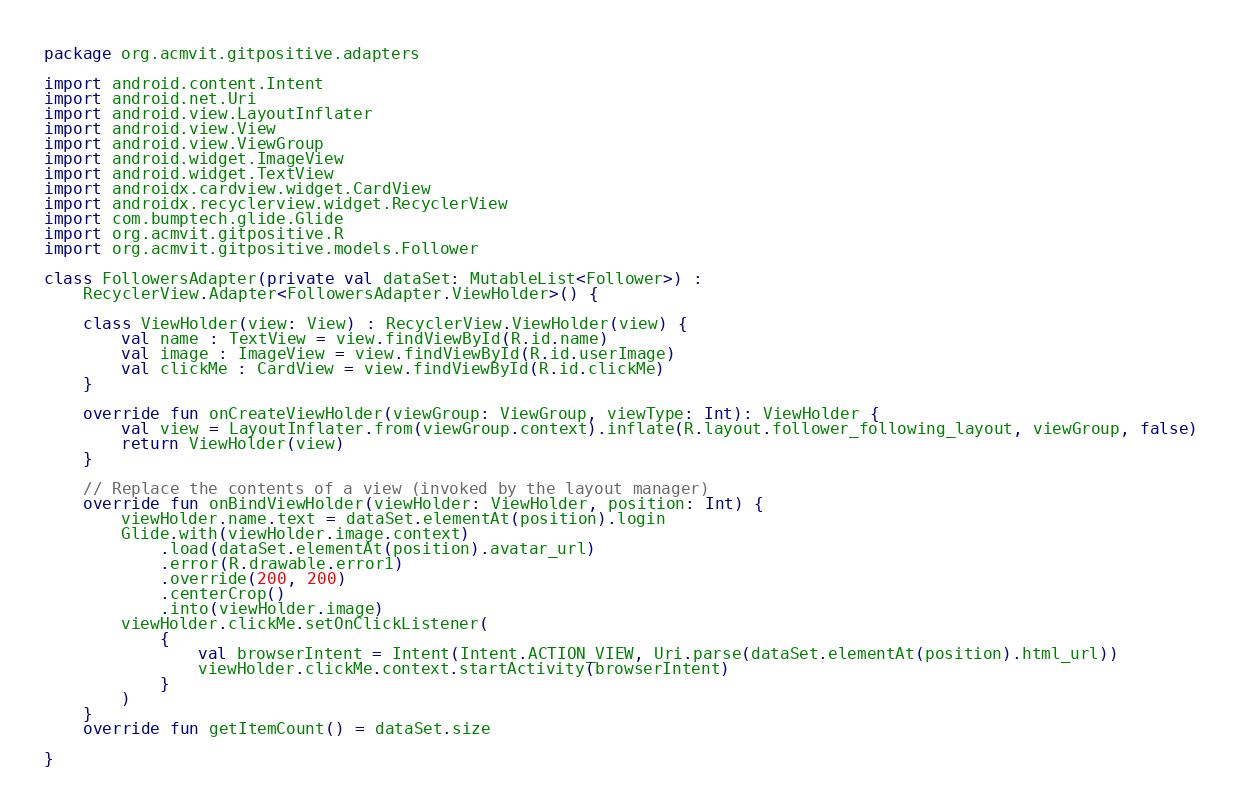<code> <loc_0><loc_0><loc_500><loc_500><_Kotlin_>package org.acmvit.gitpositive.adapters

import android.content.Intent
import android.net.Uri
import android.view.LayoutInflater
import android.view.View
import android.view.ViewGroup
import android.widget.ImageView
import android.widget.TextView
import androidx.cardview.widget.CardView
import androidx.recyclerview.widget.RecyclerView
import com.bumptech.glide.Glide
import org.acmvit.gitpositive.R
import org.acmvit.gitpositive.models.Follower

class FollowersAdapter(private val dataSet: MutableList<Follower>) :
    RecyclerView.Adapter<FollowersAdapter.ViewHolder>() {

    class ViewHolder(view: View) : RecyclerView.ViewHolder(view) {
        val name : TextView = view.findViewById(R.id.name)
        val image : ImageView = view.findViewById(R.id.userImage)
        val clickMe : CardView = view.findViewById(R.id.clickMe)
    }

    override fun onCreateViewHolder(viewGroup: ViewGroup, viewType: Int): ViewHolder {
        val view = LayoutInflater.from(viewGroup.context).inflate(R.layout.follower_following_layout, viewGroup, false)
        return ViewHolder(view)
    }

    // Replace the contents of a view (invoked by the layout manager)
    override fun onBindViewHolder(viewHolder: ViewHolder, position: Int) {
        viewHolder.name.text = dataSet.elementAt(position).login
        Glide.with(viewHolder.image.context)
            .load(dataSet.elementAt(position).avatar_url)
            .error(R.drawable.error1)
            .override(200, 200)
            .centerCrop()
            .into(viewHolder.image)
        viewHolder.clickMe.setOnClickListener(
            {
                val browserIntent = Intent(Intent.ACTION_VIEW, Uri.parse(dataSet.elementAt(position).html_url))
                viewHolder.clickMe.context.startActivity(browserIntent)
            }
        )
    }
    override fun getItemCount() = dataSet.size

}
</code> 